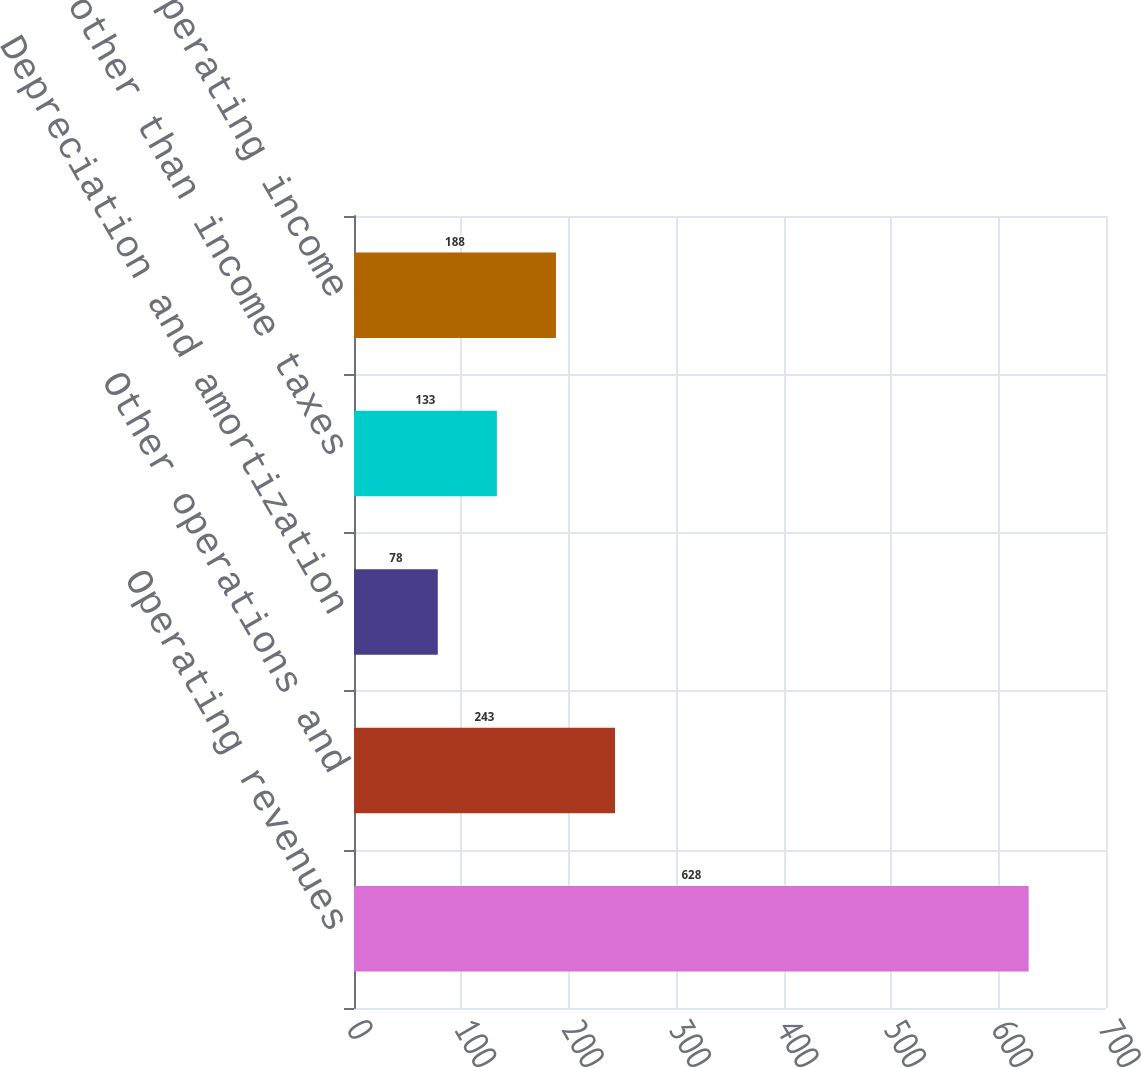Convert chart to OTSL. <chart><loc_0><loc_0><loc_500><loc_500><bar_chart><fcel>Operating revenues<fcel>Other operations and<fcel>Depreciation and amortization<fcel>Taxes other than income taxes<fcel>Operating income<nl><fcel>628<fcel>243<fcel>78<fcel>133<fcel>188<nl></chart> 